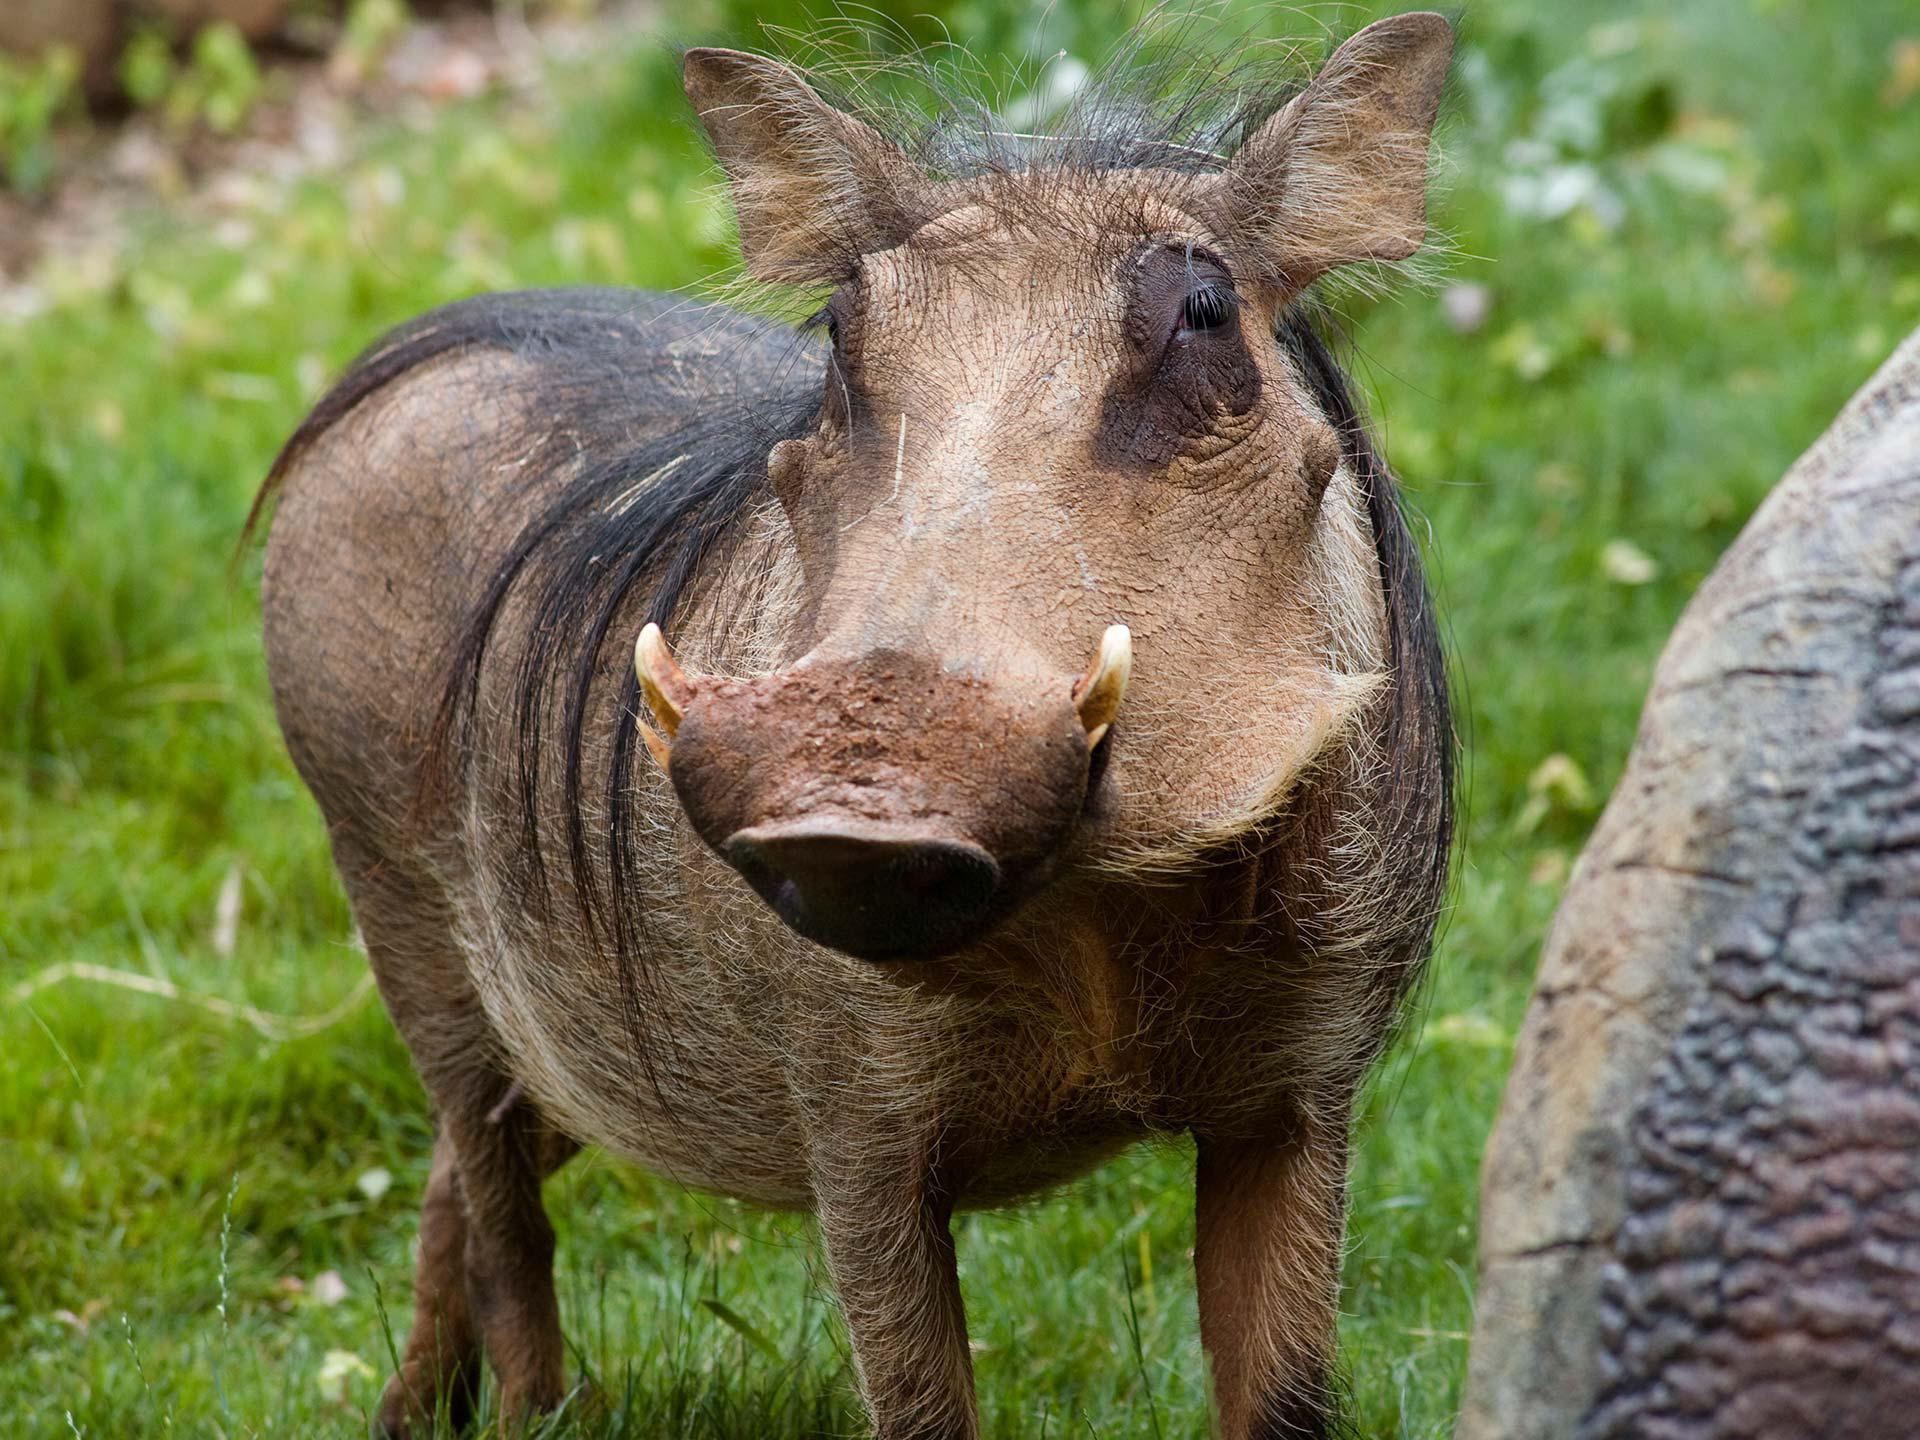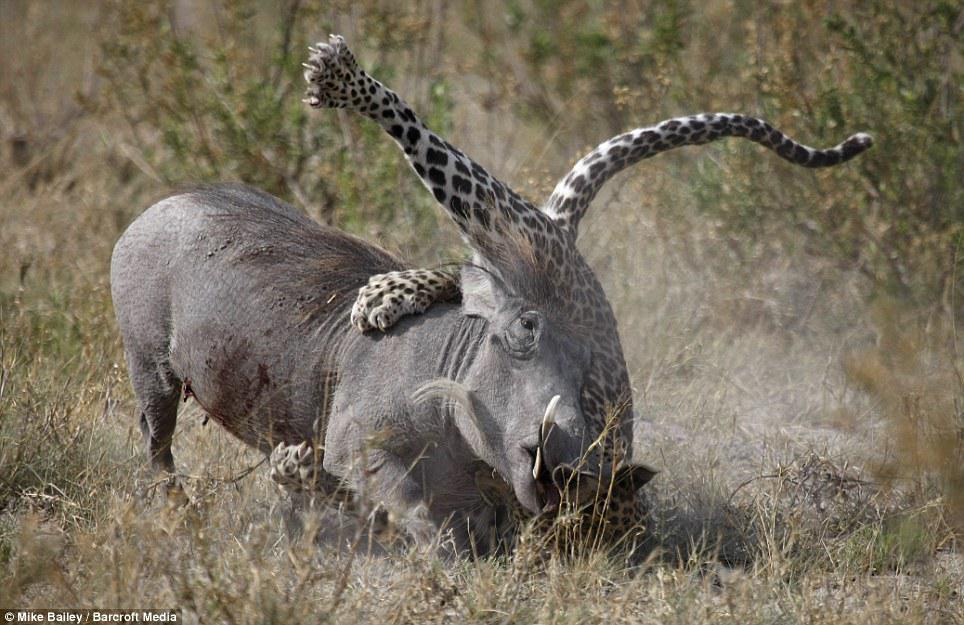The first image is the image on the left, the second image is the image on the right. Given the left and right images, does the statement "One image shows a single warthog while the other shows no less than two warthogs." hold true? Answer yes or no. No. The first image is the image on the left, the second image is the image on the right. Given the left and right images, does the statement "There are 3 warthogs in the image pair" hold true? Answer yes or no. No. 